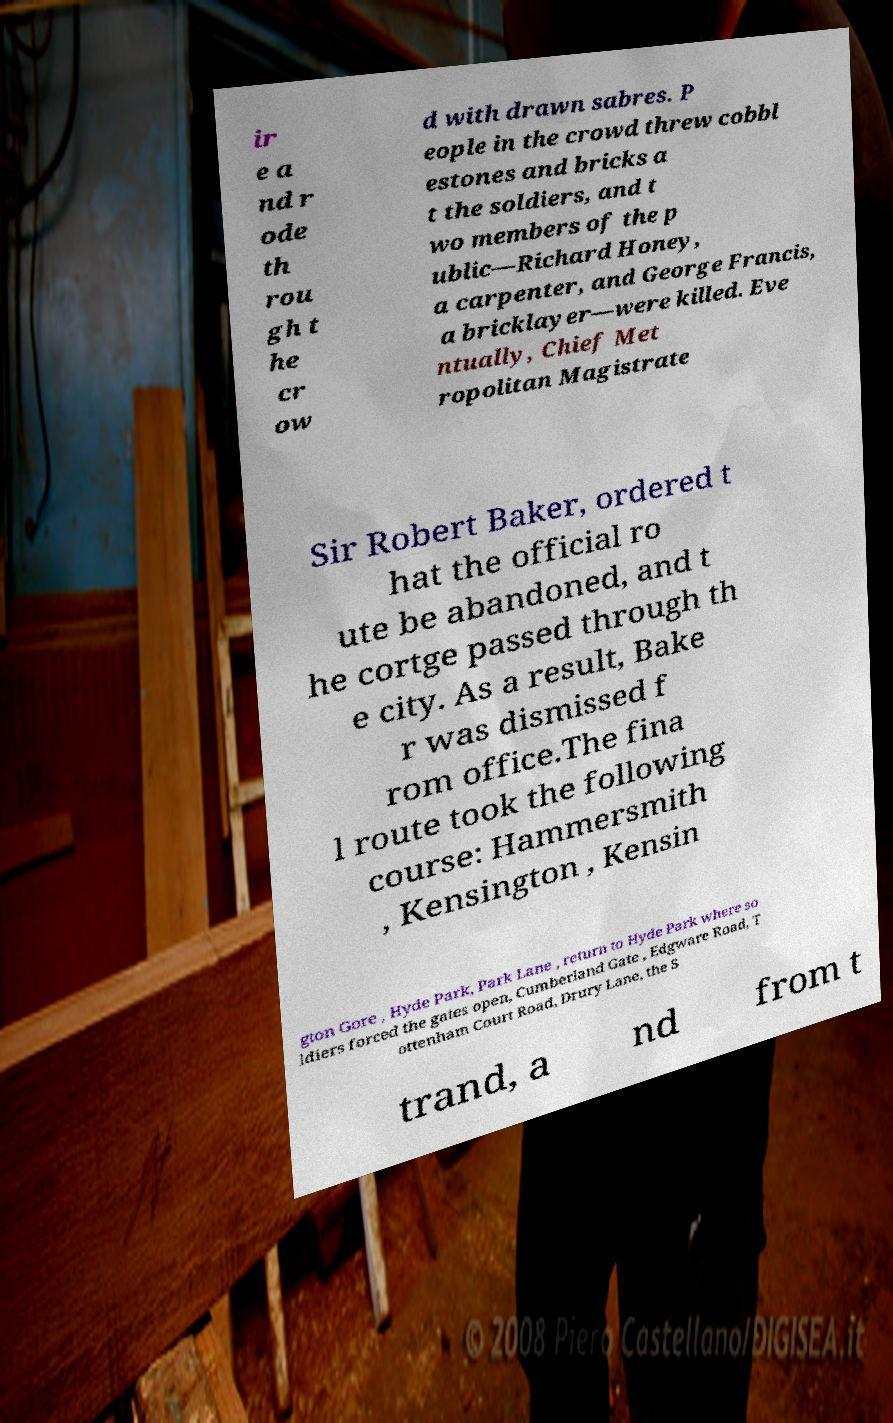There's text embedded in this image that I need extracted. Can you transcribe it verbatim? ir e a nd r ode th rou gh t he cr ow d with drawn sabres. P eople in the crowd threw cobbl estones and bricks a t the soldiers, and t wo members of the p ublic—Richard Honey, a carpenter, and George Francis, a bricklayer—were killed. Eve ntually, Chief Met ropolitan Magistrate Sir Robert Baker, ordered t hat the official ro ute be abandoned, and t he cortge passed through th e city. As a result, Bake r was dismissed f rom office.The fina l route took the following course: Hammersmith , Kensington , Kensin gton Gore , Hyde Park, Park Lane , return to Hyde Park where so ldiers forced the gates open, Cumberland Gate , Edgware Road, T ottenham Court Road, Drury Lane, the S trand, a nd from t 